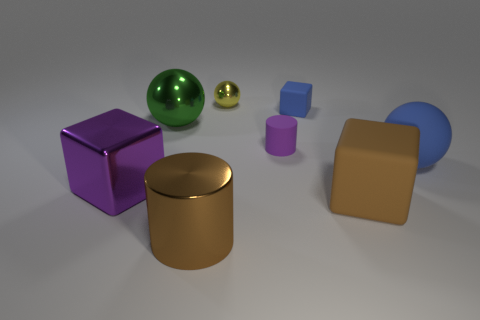Can you tell me what shapes are present in the image and their colors? Certainly! The image features a variety of geometric shapes. There's a purple cube, a green sphere, a small yellow sphere, a small blue cube, a large blue cylinder, a pink cylinder, and a golden cylinder. Each object has a distinct surface texture, ranging from matte to shiny metallic. 